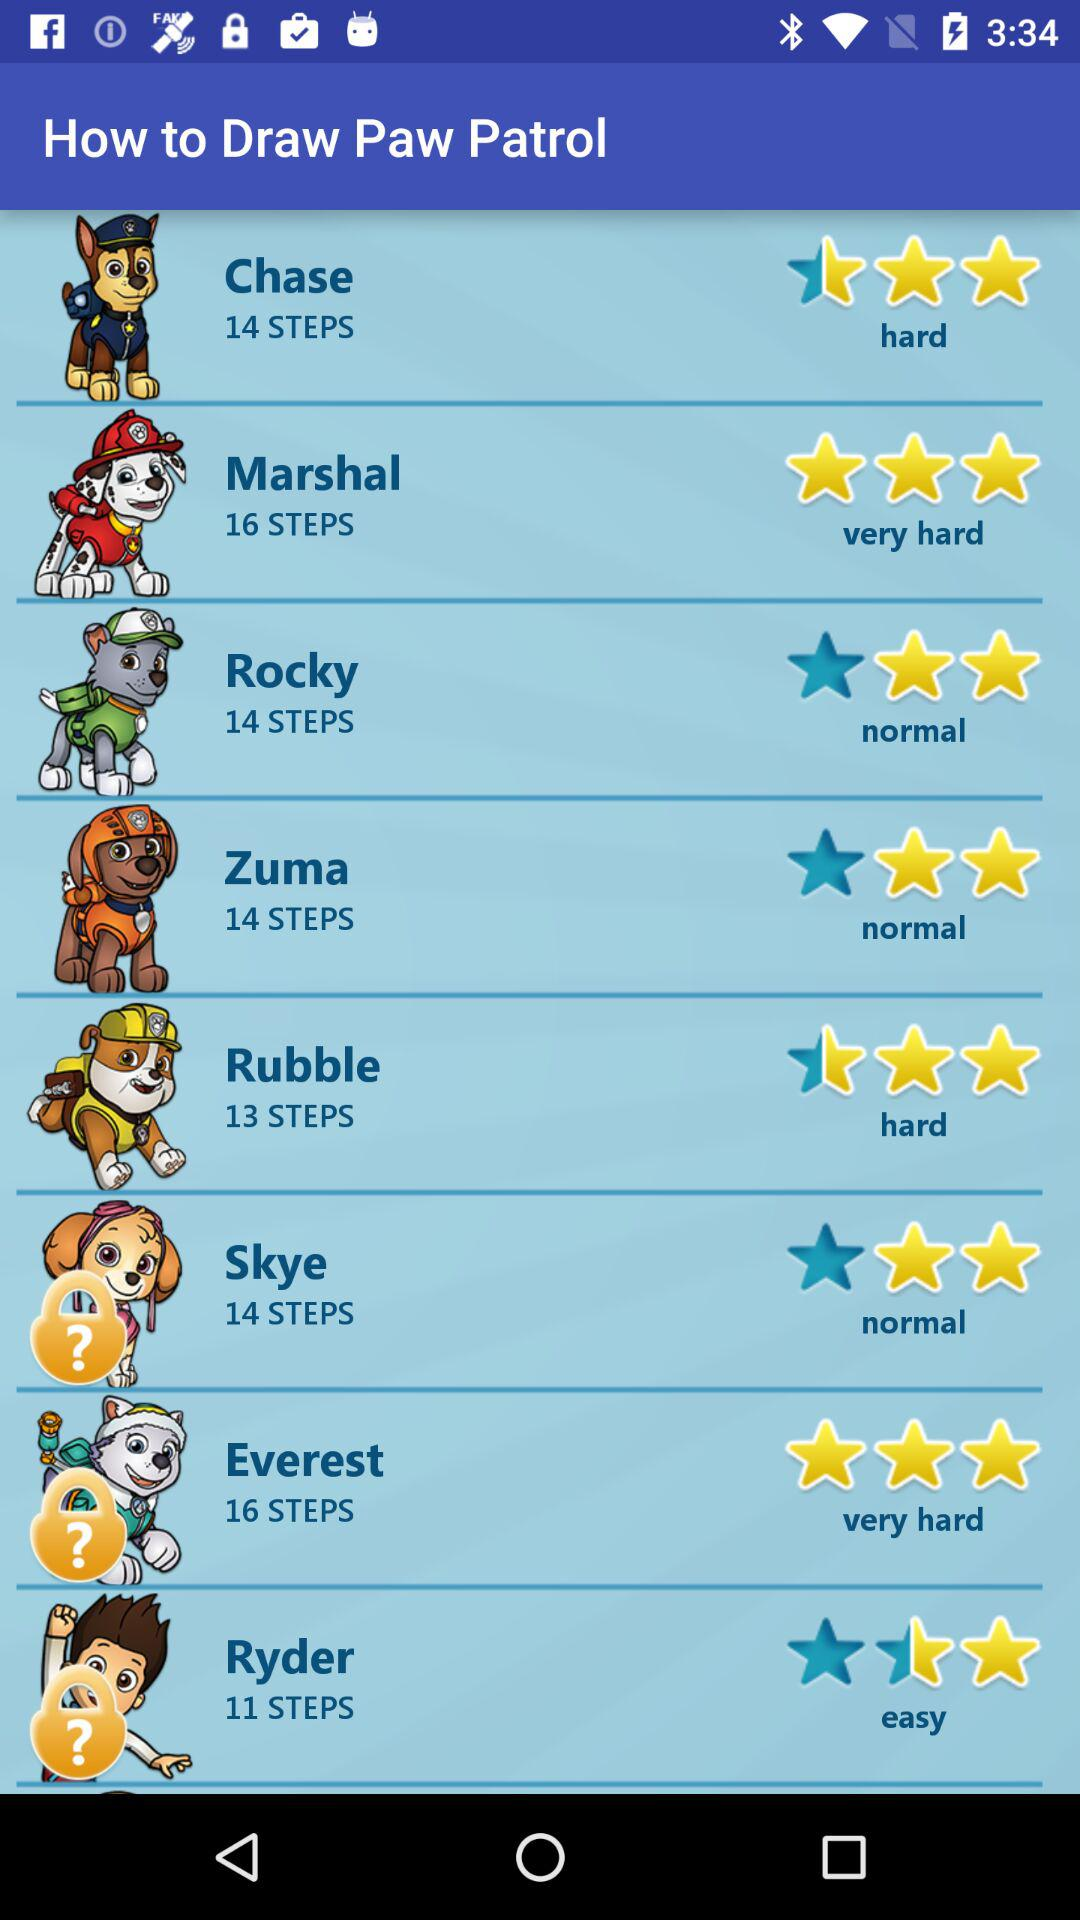What is the number of steps in "Rocky"? The number of steps is 14. 